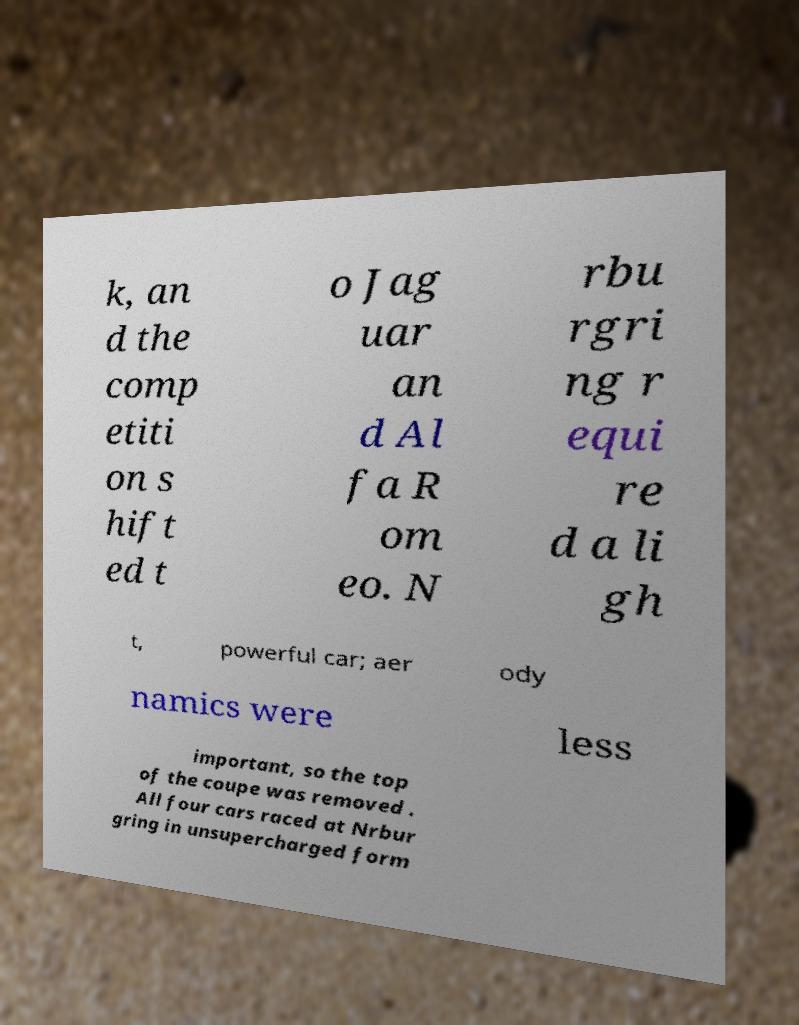Could you assist in decoding the text presented in this image and type it out clearly? k, an d the comp etiti on s hift ed t o Jag uar an d Al fa R om eo. N rbu rgri ng r equi re d a li gh t, powerful car; aer ody namics were less important, so the top of the coupe was removed . All four cars raced at Nrbur gring in unsupercharged form 